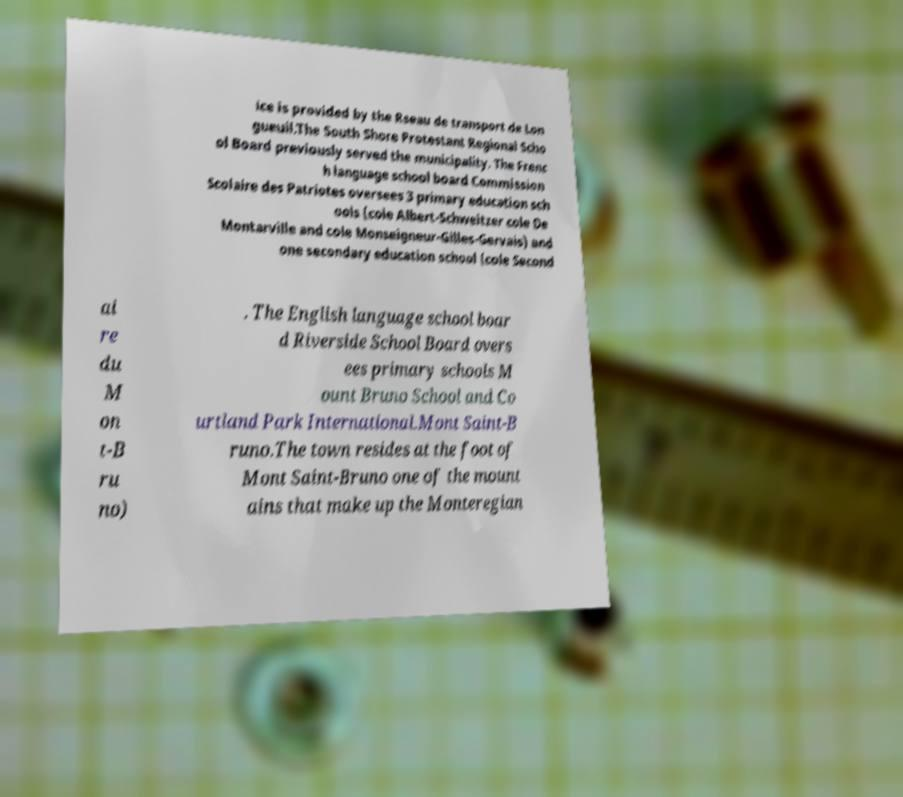There's text embedded in this image that I need extracted. Can you transcribe it verbatim? ice is provided by the Rseau de transport de Lon gueuil.The South Shore Protestant Regional Scho ol Board previously served the municipality. The Frenc h language school board Commission Scolaire des Patriotes oversees 3 primary education sch ools (cole Albert-Schweitzer cole De Montarville and cole Monseigneur-Gilles-Gervais) and one secondary education school (cole Second ai re du M on t-B ru no) . The English language school boar d Riverside School Board overs ees primary schools M ount Bruno School and Co urtland Park International.Mont Saint-B runo.The town resides at the foot of Mont Saint-Bruno one of the mount ains that make up the Monteregian 